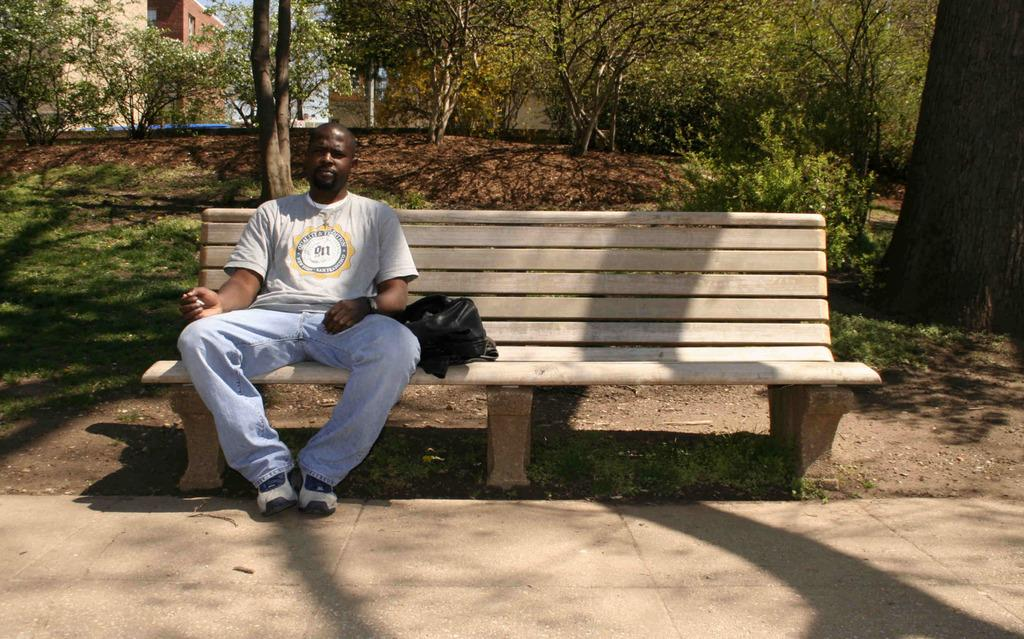What is the man in the image doing? The man is sitting on a bench in the image. What is located beside the man? There is a bag beside the man. What can be seen in the background of the image? There are buildings, trees, and the sky visible in the background of the image. What type of lumber is the man using to make a point in the image? There is no lumber or any indication of the man making a point in the image. 